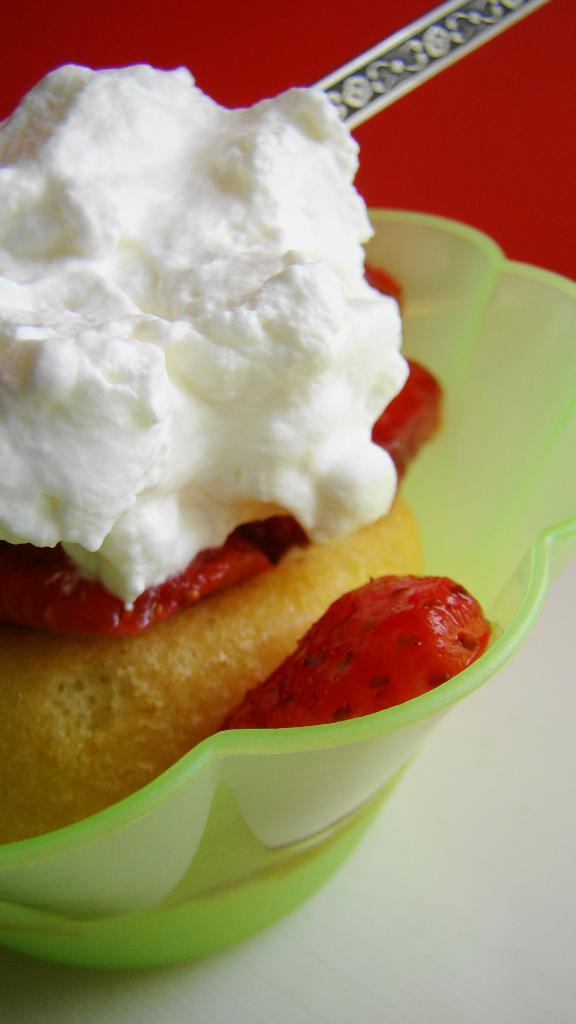What color is the bowl in the image? The bowl in the image is green-colored. What is inside the bowl? The bowl contains different types of food. Can you describe the background of the image? The background of the image has a red color visible. How does the whip affect the system in the image? There is no whip or system present in the image. 